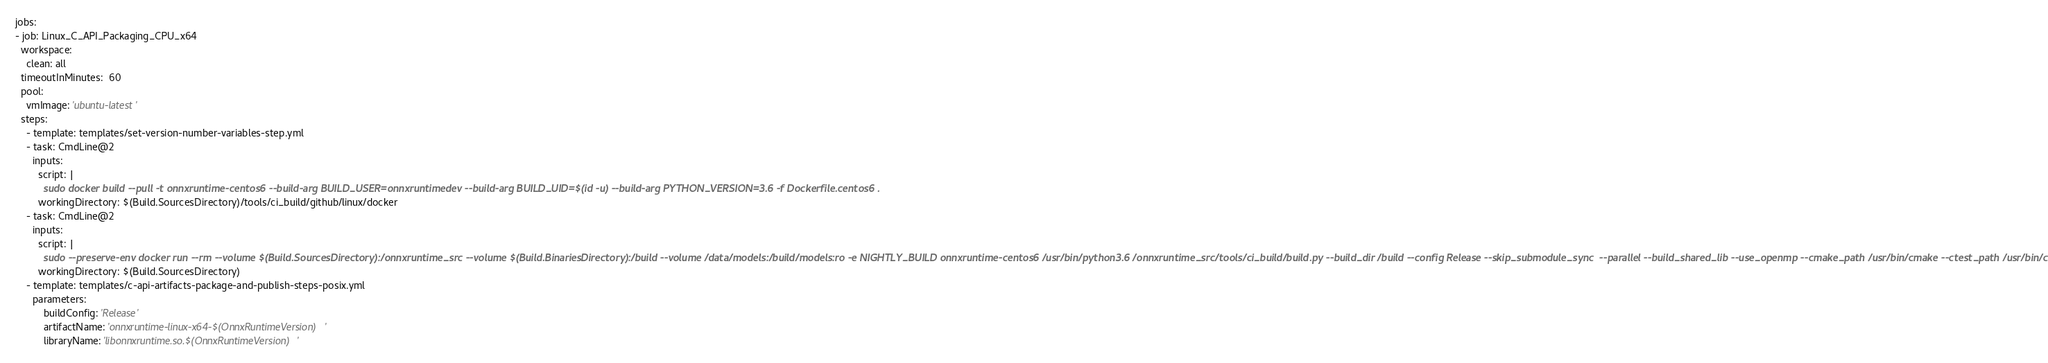Convert code to text. <code><loc_0><loc_0><loc_500><loc_500><_YAML_>jobs:
- job: Linux_C_API_Packaging_CPU_x64
  workspace:
    clean: all
  timeoutInMinutes:  60
  pool:
    vmImage: 'ubuntu-latest'
  steps:
    - template: templates/set-version-number-variables-step.yml
    - task: CmdLine@2
      inputs:
        script: |
          sudo docker build --pull -t onnxruntime-centos6 --build-arg BUILD_USER=onnxruntimedev --build-arg BUILD_UID=$(id -u) --build-arg PYTHON_VERSION=3.6 -f Dockerfile.centos6 .
        workingDirectory: $(Build.SourcesDirectory)/tools/ci_build/github/linux/docker
    - task: CmdLine@2
      inputs:
        script: |
          sudo --preserve-env docker run --rm --volume $(Build.SourcesDirectory):/onnxruntime_src --volume $(Build.BinariesDirectory):/build --volume /data/models:/build/models:ro -e NIGHTLY_BUILD onnxruntime-centos6 /usr/bin/python3.6 /onnxruntime_src/tools/ci_build/build.py --build_dir /build --config Release --skip_submodule_sync  --parallel --build_shared_lib --use_openmp --cmake_path /usr/bin/cmake --ctest_path /usr/bin/ctest
        workingDirectory: $(Build.SourcesDirectory)
    - template: templates/c-api-artifacts-package-and-publish-steps-posix.yml
      parameters:
          buildConfig: 'Release'
          artifactName: 'onnxruntime-linux-x64-$(OnnxRuntimeVersion)'
          libraryName: 'libonnxruntime.so.$(OnnxRuntimeVersion)'</code> 